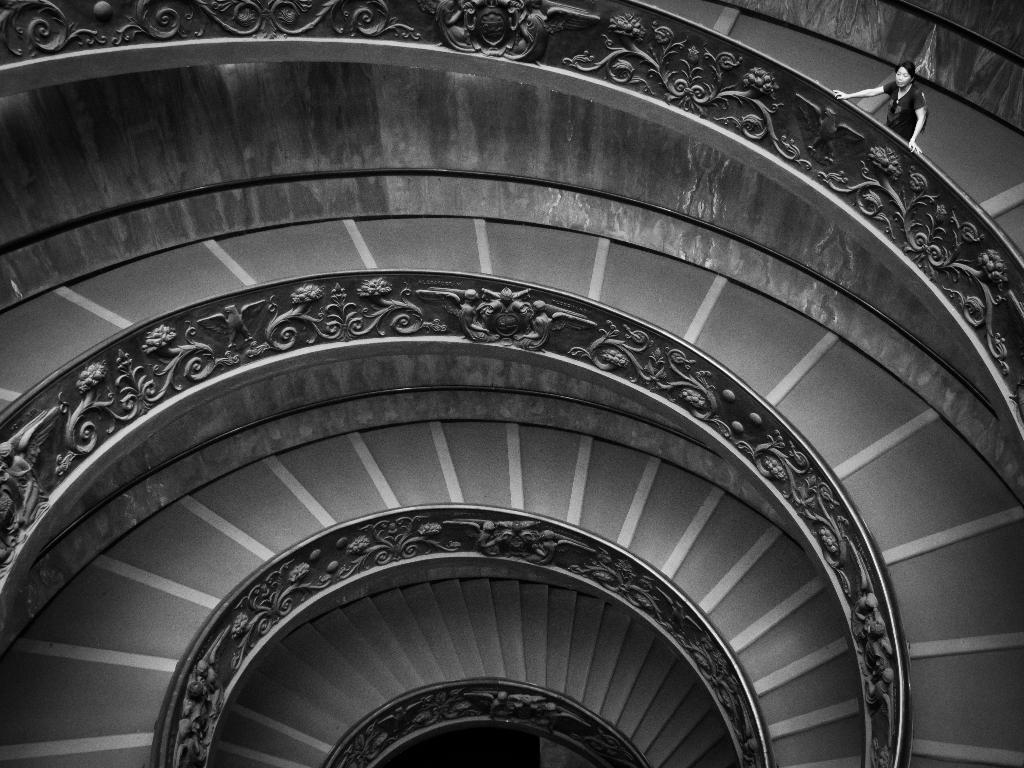What is the color scheme of the image? The image is black and white. What type of architectural feature is present in the image? There is a spiral staircase in the image. Can you describe the person's position in the image? The person is standing on the steps of the staircase and is located in the right top corner of the image. What else can be seen in the image besides the staircase and the person? There is a wall in the image. What type of curtain is hanging from the staircase in the image? There is no curtain present in the image; it features a spiral staircase and a person standing on the steps. How many twists can be seen in the staircase in the image? The number of twists in the spiral staircase cannot be determined from the image alone, as it only provides a partial view of the staircase. 